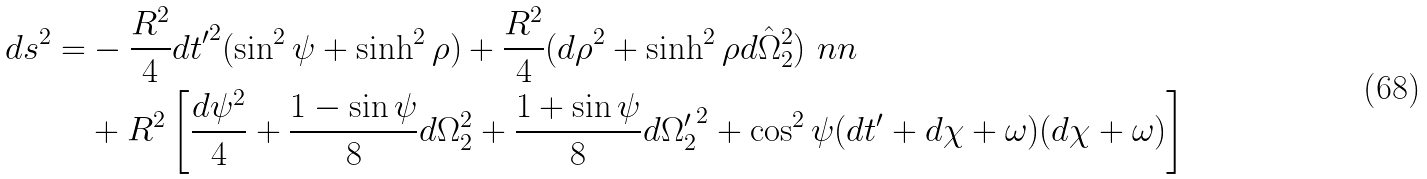<formula> <loc_0><loc_0><loc_500><loc_500>d s ^ { 2 } = & - \frac { R ^ { 2 } } { 4 } { d t ^ { \prime } } ^ { 2 } ( \sin ^ { 2 } \psi + \sinh ^ { 2 } \rho ) + \frac { R ^ { 2 } } { 4 } ( d \rho ^ { 2 } + \sinh ^ { 2 } \rho d \hat { \Omega } _ { 2 } ^ { 2 } ) \ n n \\ & + R ^ { 2 } \left [ \frac { d \psi ^ { 2 } } { 4 } + \frac { 1 - \sin \psi } { 8 } d \Omega _ { 2 } ^ { 2 } + \frac { 1 + \sin \psi } { 8 } d { \Omega _ { 2 } ^ { \prime } } ^ { 2 } + \cos ^ { 2 } \psi ( d t ^ { \prime } + d \chi + \omega ) ( d \chi + \omega ) \right ]</formula> 